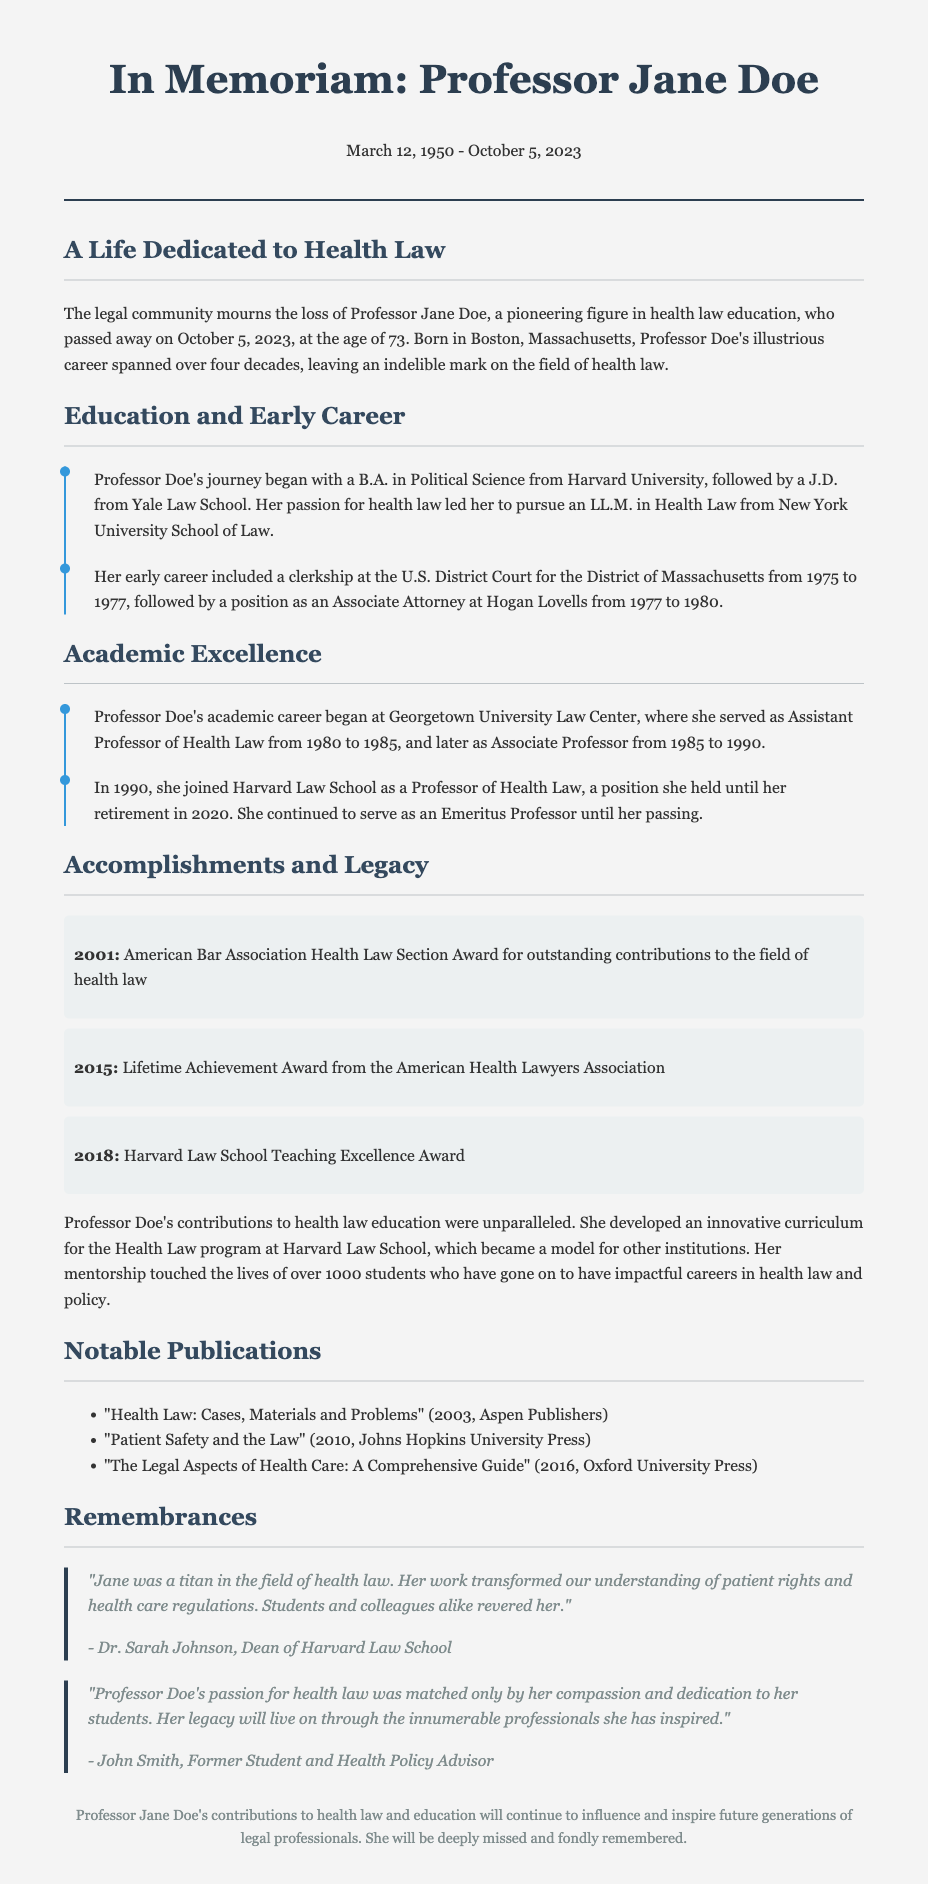What was Professor Jane Doe's birth date? The document states that Professor Jane Doe was born on March 12, 1950.
Answer: March 12, 1950 What year did Professor Doe pass away? The obituary indicates that she passed away on October 5, 2023.
Answer: October 5, 2023 Which university awarded Professor Doe an LL.M. in Health Law? The document mentions that she pursued her LL.M. at New York University School of Law.
Answer: New York University School of Law How many students did Professor Doe mentor? The obituary highlights that she mentored over 1000 students.
Answer: over 1000 What award did Professor Doe receive in 2015? The document states that she received the Lifetime Achievement Award from the American Health Lawyers Association in 2015.
Answer: Lifetime Achievement Award from the American Health Lawyers Association Why is Professor Doe's curriculum considered notable? The obituary notes that her curriculum became a model for other institutions.
Answer: Became a model for other institutions What role did Professor Doe hold at Harvard Law School before her retirement? It states that she was a Professor of Health Law until her retirement in 2020.
Answer: Professor of Health Law Which publication did Professor Doe release in 2016? The document lists "The Legal Aspects of Health Care: A Comprehensive Guide" as her publication in 2016.
Answer: The Legal Aspects of Health Care: A Comprehensive Guide Who described Professor Doe as a titan in the field of health law? Dr. Sarah Johnson, Dean of Harvard Law School is quoted describing her as such.
Answer: Dr. Sarah Johnson 